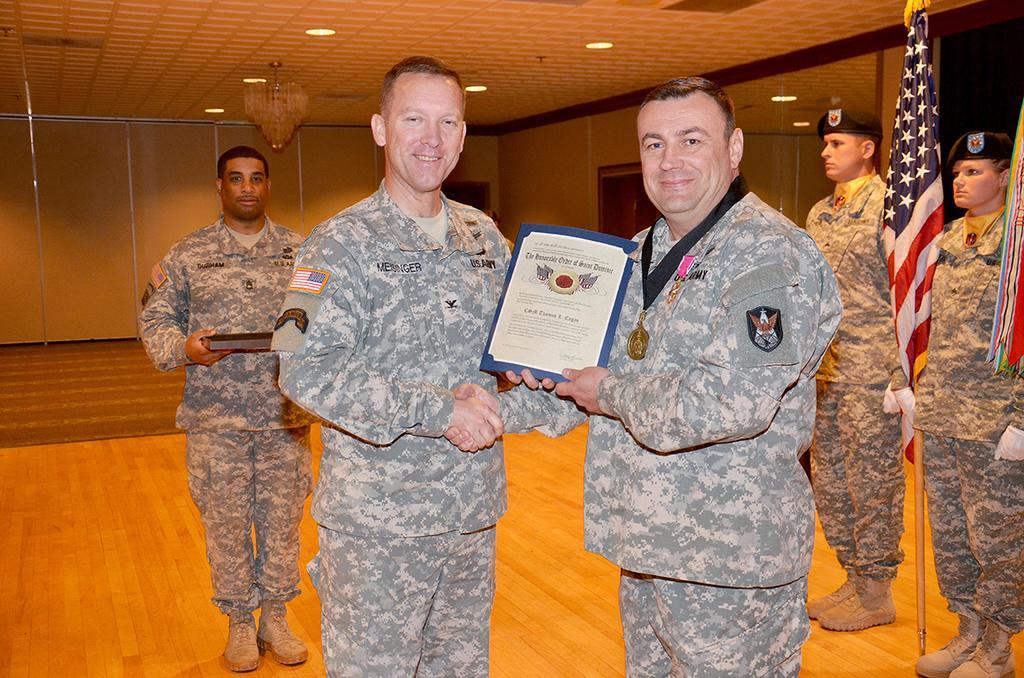Could you give a brief overview of what you see in this image? There are two men holding something in the hand. One man is wearing a medal with tag. In the back a person is holding something in the hand. On the right side there is a woman and a man wearing cap and gloves is standing. Also there is a flag. On the ceiling there are lights and chandelier. In the back there is a wall. 